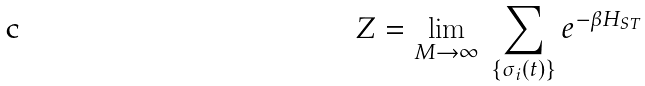Convert formula to latex. <formula><loc_0><loc_0><loc_500><loc_500>Z = \lim _ { M \to \infty } \ \sum _ { \left \{ \sigma _ { i } ( t ) \right \} } e ^ { - \beta H _ { S T } }</formula> 